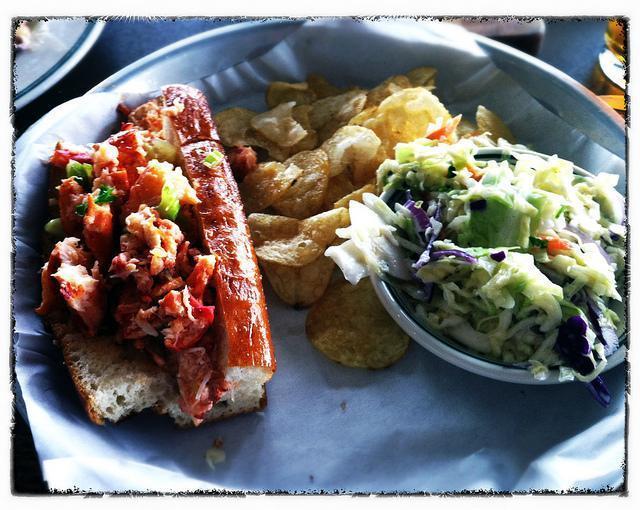How many bowls are in the picture?
Give a very brief answer. 1. 